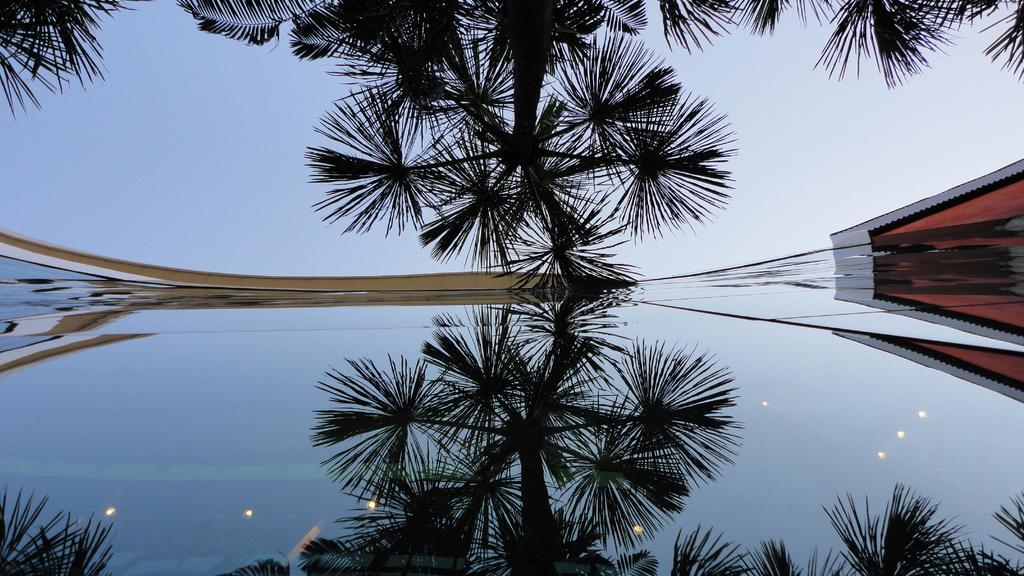Describe this image in one or two sentences. At the bottom of the image there is water with reflection of trees with leaves, lights and roof. Behind the water there is a tree and also there is a roof. At the top of the image in the background there is a sky. 